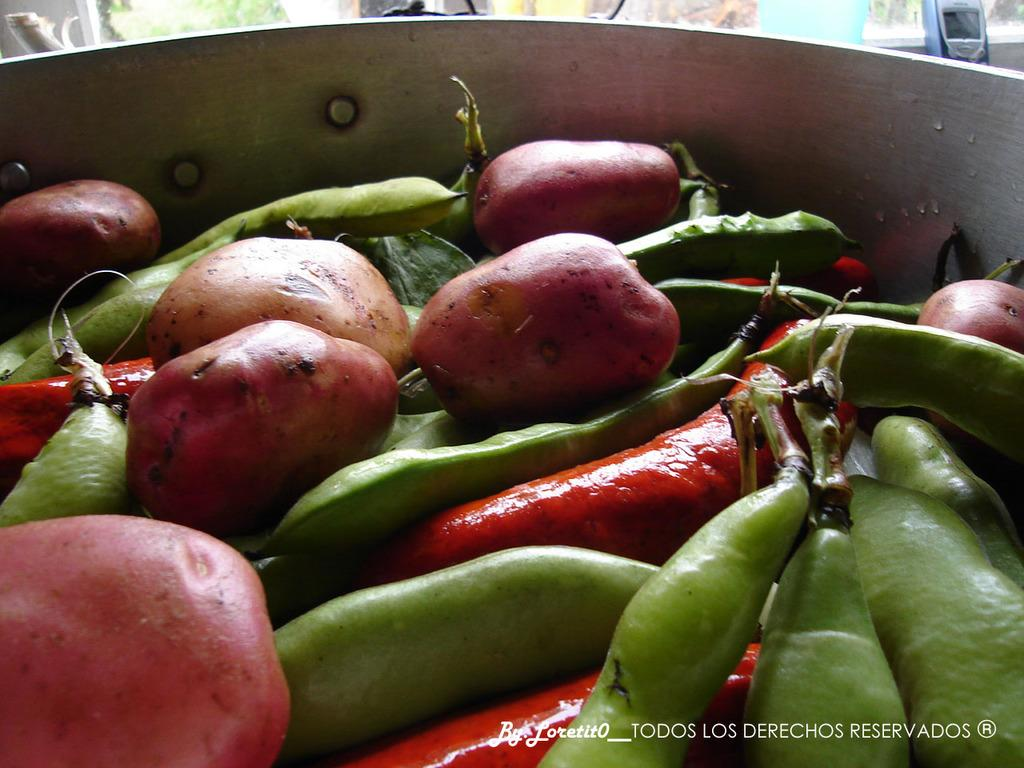What is in the bowl that is visible in the image? The bowl contains potatoes, beans, and red chillies. What other object can be seen in the image besides the bowl? There is a mobile phone in the image. What is the income of the door in the image? There is no door present in the image, and therefore no income can be associated with it. 